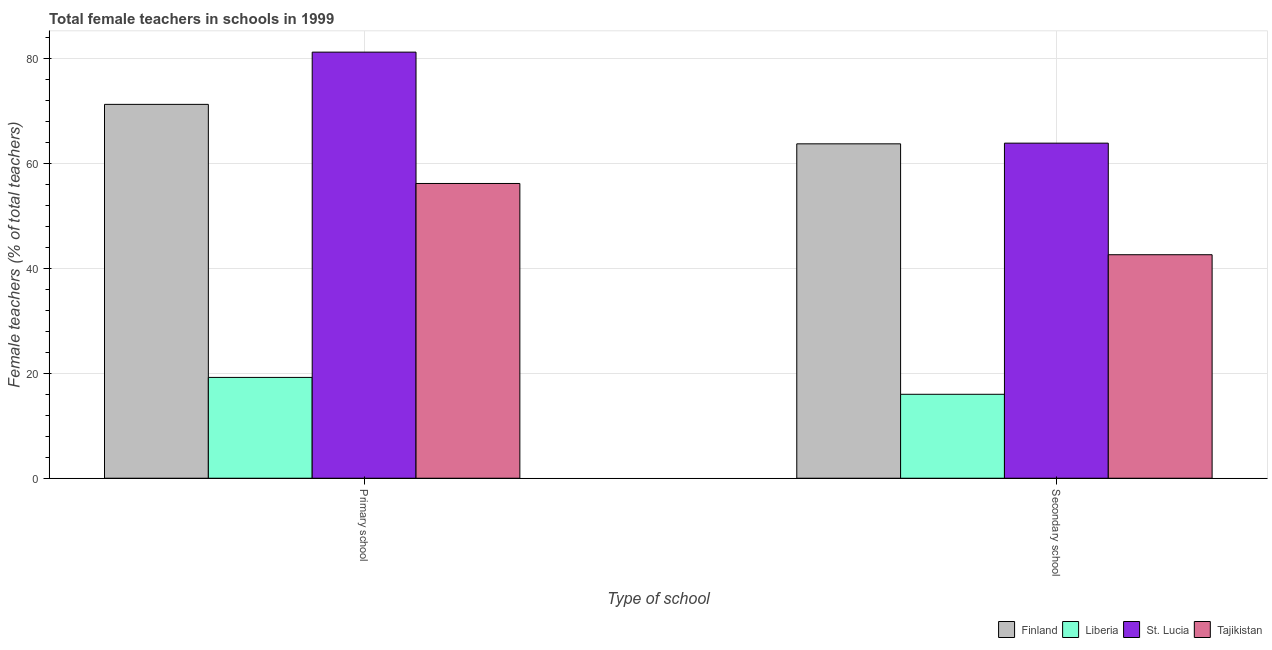How many different coloured bars are there?
Offer a very short reply. 4. How many bars are there on the 2nd tick from the right?
Keep it short and to the point. 4. What is the label of the 1st group of bars from the left?
Provide a short and direct response. Primary school. What is the percentage of female teachers in primary schools in Finland?
Your answer should be compact. 71.21. Across all countries, what is the maximum percentage of female teachers in secondary schools?
Provide a succinct answer. 63.83. Across all countries, what is the minimum percentage of female teachers in primary schools?
Keep it short and to the point. 19.2. In which country was the percentage of female teachers in secondary schools maximum?
Your answer should be very brief. St. Lucia. In which country was the percentage of female teachers in secondary schools minimum?
Provide a succinct answer. Liberia. What is the total percentage of female teachers in primary schools in the graph?
Your answer should be compact. 227.73. What is the difference between the percentage of female teachers in primary schools in Finland and that in Liberia?
Offer a terse response. 52.01. What is the difference between the percentage of female teachers in secondary schools in Liberia and the percentage of female teachers in primary schools in Finland?
Offer a terse response. -55.22. What is the average percentage of female teachers in secondary schools per country?
Ensure brevity in your answer.  46.52. What is the difference between the percentage of female teachers in secondary schools and percentage of female teachers in primary schools in St. Lucia?
Make the answer very short. -17.34. In how many countries, is the percentage of female teachers in secondary schools greater than 72 %?
Your answer should be compact. 0. What is the ratio of the percentage of female teachers in secondary schools in Liberia to that in St. Lucia?
Provide a short and direct response. 0.25. In how many countries, is the percentage of female teachers in secondary schools greater than the average percentage of female teachers in secondary schools taken over all countries?
Your answer should be very brief. 2. What does the 2nd bar from the left in Primary school represents?
Your response must be concise. Liberia. What does the 3rd bar from the right in Secondary school represents?
Give a very brief answer. Liberia. How many bars are there?
Your response must be concise. 8. What is the difference between two consecutive major ticks on the Y-axis?
Make the answer very short. 20. Does the graph contain grids?
Keep it short and to the point. Yes. Where does the legend appear in the graph?
Make the answer very short. Bottom right. How are the legend labels stacked?
Keep it short and to the point. Horizontal. What is the title of the graph?
Make the answer very short. Total female teachers in schools in 1999. What is the label or title of the X-axis?
Make the answer very short. Type of school. What is the label or title of the Y-axis?
Offer a very short reply. Female teachers (% of total teachers). What is the Female teachers (% of total teachers) of Finland in Primary school?
Keep it short and to the point. 71.21. What is the Female teachers (% of total teachers) in Liberia in Primary school?
Provide a succinct answer. 19.2. What is the Female teachers (% of total teachers) in St. Lucia in Primary school?
Offer a very short reply. 81.16. What is the Female teachers (% of total teachers) of Tajikistan in Primary school?
Make the answer very short. 56.15. What is the Female teachers (% of total teachers) in Finland in Secondary school?
Your response must be concise. 63.7. What is the Female teachers (% of total teachers) in Liberia in Secondary school?
Keep it short and to the point. 15.99. What is the Female teachers (% of total teachers) in St. Lucia in Secondary school?
Make the answer very short. 63.83. What is the Female teachers (% of total teachers) in Tajikistan in Secondary school?
Keep it short and to the point. 42.57. Across all Type of school, what is the maximum Female teachers (% of total teachers) of Finland?
Offer a very short reply. 71.21. Across all Type of school, what is the maximum Female teachers (% of total teachers) of Liberia?
Provide a succinct answer. 19.2. Across all Type of school, what is the maximum Female teachers (% of total teachers) of St. Lucia?
Make the answer very short. 81.16. Across all Type of school, what is the maximum Female teachers (% of total teachers) of Tajikistan?
Your answer should be compact. 56.15. Across all Type of school, what is the minimum Female teachers (% of total teachers) of Finland?
Provide a short and direct response. 63.7. Across all Type of school, what is the minimum Female teachers (% of total teachers) of Liberia?
Provide a short and direct response. 15.99. Across all Type of school, what is the minimum Female teachers (% of total teachers) in St. Lucia?
Make the answer very short. 63.83. Across all Type of school, what is the minimum Female teachers (% of total teachers) of Tajikistan?
Offer a very short reply. 42.57. What is the total Female teachers (% of total teachers) in Finland in the graph?
Keep it short and to the point. 134.91. What is the total Female teachers (% of total teachers) of Liberia in the graph?
Offer a very short reply. 35.19. What is the total Female teachers (% of total teachers) in St. Lucia in the graph?
Offer a very short reply. 144.99. What is the total Female teachers (% of total teachers) of Tajikistan in the graph?
Offer a terse response. 98.72. What is the difference between the Female teachers (% of total teachers) of Finland in Primary school and that in Secondary school?
Your answer should be compact. 7.52. What is the difference between the Female teachers (% of total teachers) in Liberia in Primary school and that in Secondary school?
Your answer should be very brief. 3.21. What is the difference between the Female teachers (% of total teachers) of St. Lucia in Primary school and that in Secondary school?
Ensure brevity in your answer.  17.34. What is the difference between the Female teachers (% of total teachers) of Tajikistan in Primary school and that in Secondary school?
Provide a short and direct response. 13.57. What is the difference between the Female teachers (% of total teachers) in Finland in Primary school and the Female teachers (% of total teachers) in Liberia in Secondary school?
Offer a terse response. 55.22. What is the difference between the Female teachers (% of total teachers) of Finland in Primary school and the Female teachers (% of total teachers) of St. Lucia in Secondary school?
Make the answer very short. 7.39. What is the difference between the Female teachers (% of total teachers) of Finland in Primary school and the Female teachers (% of total teachers) of Tajikistan in Secondary school?
Your answer should be very brief. 28.64. What is the difference between the Female teachers (% of total teachers) of Liberia in Primary school and the Female teachers (% of total teachers) of St. Lucia in Secondary school?
Provide a short and direct response. -44.62. What is the difference between the Female teachers (% of total teachers) in Liberia in Primary school and the Female teachers (% of total teachers) in Tajikistan in Secondary school?
Provide a succinct answer. -23.37. What is the difference between the Female teachers (% of total teachers) of St. Lucia in Primary school and the Female teachers (% of total teachers) of Tajikistan in Secondary school?
Keep it short and to the point. 38.59. What is the average Female teachers (% of total teachers) of Finland per Type of school?
Provide a succinct answer. 67.46. What is the average Female teachers (% of total teachers) of Liberia per Type of school?
Your response must be concise. 17.6. What is the average Female teachers (% of total teachers) in St. Lucia per Type of school?
Your answer should be very brief. 72.5. What is the average Female teachers (% of total teachers) of Tajikistan per Type of school?
Your answer should be very brief. 49.36. What is the difference between the Female teachers (% of total teachers) of Finland and Female teachers (% of total teachers) of Liberia in Primary school?
Offer a terse response. 52.01. What is the difference between the Female teachers (% of total teachers) of Finland and Female teachers (% of total teachers) of St. Lucia in Primary school?
Provide a short and direct response. -9.95. What is the difference between the Female teachers (% of total teachers) of Finland and Female teachers (% of total teachers) of Tajikistan in Primary school?
Your response must be concise. 15.07. What is the difference between the Female teachers (% of total teachers) of Liberia and Female teachers (% of total teachers) of St. Lucia in Primary school?
Provide a short and direct response. -61.96. What is the difference between the Female teachers (% of total teachers) of Liberia and Female teachers (% of total teachers) of Tajikistan in Primary school?
Provide a short and direct response. -36.94. What is the difference between the Female teachers (% of total teachers) in St. Lucia and Female teachers (% of total teachers) in Tajikistan in Primary school?
Provide a succinct answer. 25.02. What is the difference between the Female teachers (% of total teachers) of Finland and Female teachers (% of total teachers) of Liberia in Secondary school?
Your response must be concise. 47.71. What is the difference between the Female teachers (% of total teachers) in Finland and Female teachers (% of total teachers) in St. Lucia in Secondary school?
Make the answer very short. -0.13. What is the difference between the Female teachers (% of total teachers) of Finland and Female teachers (% of total teachers) of Tajikistan in Secondary school?
Your response must be concise. 21.12. What is the difference between the Female teachers (% of total teachers) of Liberia and Female teachers (% of total teachers) of St. Lucia in Secondary school?
Provide a succinct answer. -47.84. What is the difference between the Female teachers (% of total teachers) of Liberia and Female teachers (% of total teachers) of Tajikistan in Secondary school?
Give a very brief answer. -26.58. What is the difference between the Female teachers (% of total teachers) in St. Lucia and Female teachers (% of total teachers) in Tajikistan in Secondary school?
Offer a terse response. 21.25. What is the ratio of the Female teachers (% of total teachers) in Finland in Primary school to that in Secondary school?
Make the answer very short. 1.12. What is the ratio of the Female teachers (% of total teachers) of Liberia in Primary school to that in Secondary school?
Provide a succinct answer. 1.2. What is the ratio of the Female teachers (% of total teachers) of St. Lucia in Primary school to that in Secondary school?
Provide a succinct answer. 1.27. What is the ratio of the Female teachers (% of total teachers) in Tajikistan in Primary school to that in Secondary school?
Your answer should be compact. 1.32. What is the difference between the highest and the second highest Female teachers (% of total teachers) in Finland?
Provide a short and direct response. 7.52. What is the difference between the highest and the second highest Female teachers (% of total teachers) of Liberia?
Ensure brevity in your answer.  3.21. What is the difference between the highest and the second highest Female teachers (% of total teachers) in St. Lucia?
Your response must be concise. 17.34. What is the difference between the highest and the second highest Female teachers (% of total teachers) of Tajikistan?
Make the answer very short. 13.57. What is the difference between the highest and the lowest Female teachers (% of total teachers) of Finland?
Ensure brevity in your answer.  7.52. What is the difference between the highest and the lowest Female teachers (% of total teachers) in Liberia?
Provide a succinct answer. 3.21. What is the difference between the highest and the lowest Female teachers (% of total teachers) in St. Lucia?
Make the answer very short. 17.34. What is the difference between the highest and the lowest Female teachers (% of total teachers) of Tajikistan?
Your response must be concise. 13.57. 